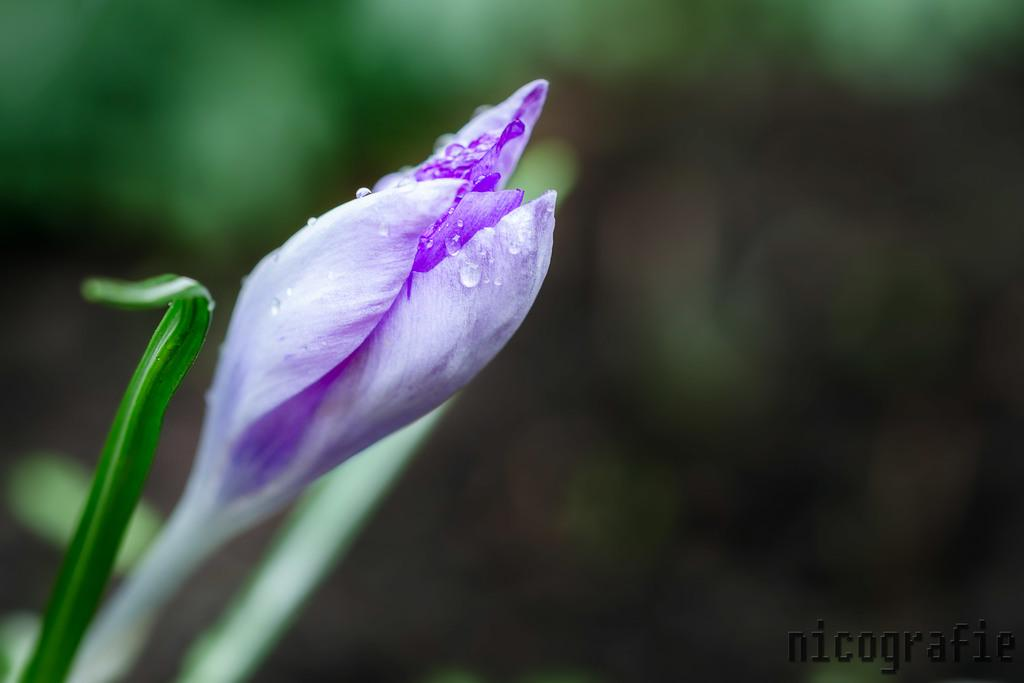What is the main subject of the image? The main subject of the image is a flower. Can you describe the flower in more detail? Yes, there are small droplets on the flower, and it has a leaf attached to it, suggesting it may be part of a plant. What can be said about the background of the image? The background of the image is blurry. What type of copper quill is used to write on the meat in the image? There is no copper quill or meat present in the image; it features a flower with droplets and a blurry background. 